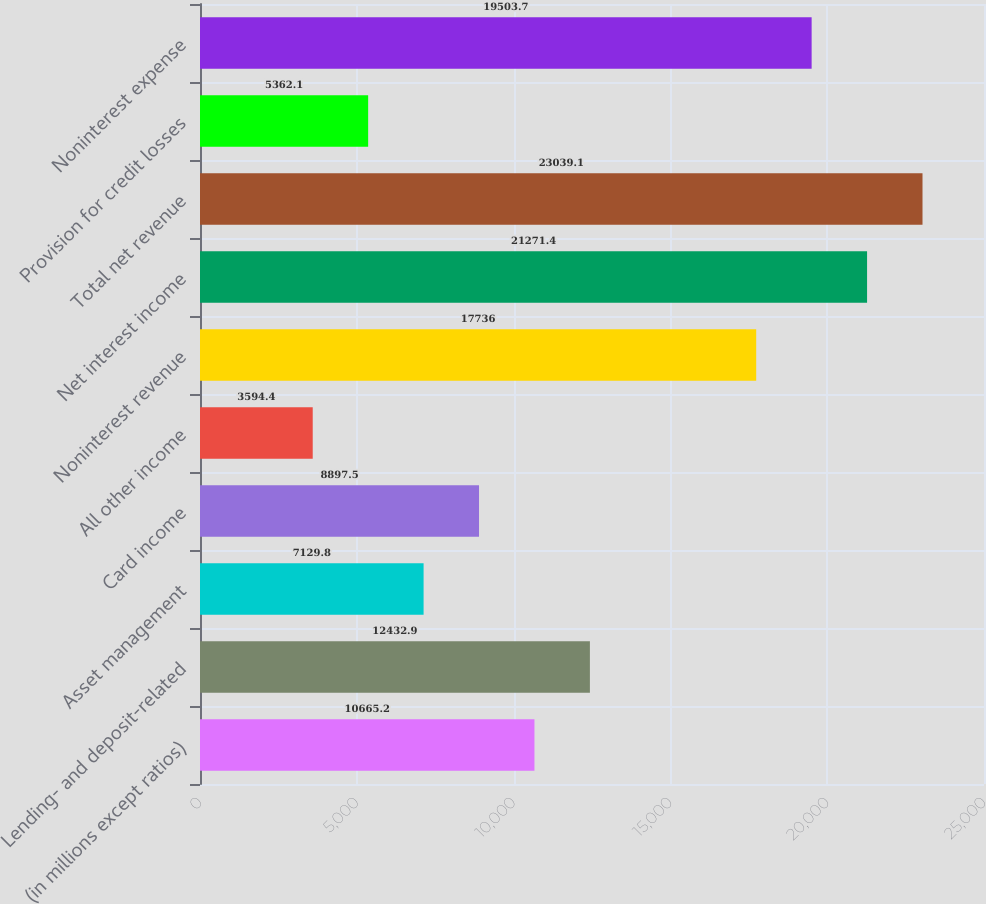<chart> <loc_0><loc_0><loc_500><loc_500><bar_chart><fcel>(in millions except ratios)<fcel>Lending- and deposit-related<fcel>Asset management<fcel>Card income<fcel>All other income<fcel>Noninterest revenue<fcel>Net interest income<fcel>Total net revenue<fcel>Provision for credit losses<fcel>Noninterest expense<nl><fcel>10665.2<fcel>12432.9<fcel>7129.8<fcel>8897.5<fcel>3594.4<fcel>17736<fcel>21271.4<fcel>23039.1<fcel>5362.1<fcel>19503.7<nl></chart> 